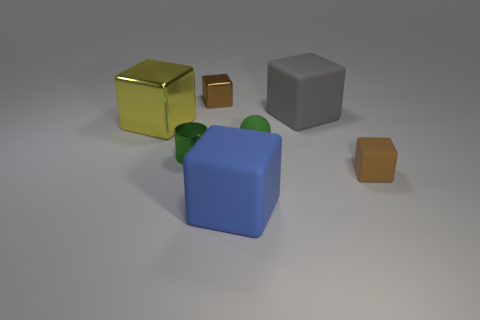Subtract all gray matte blocks. How many blocks are left? 4 Subtract all gray cylinders. How many brown cubes are left? 2 Subtract all brown cubes. How many cubes are left? 3 Add 1 big gray matte things. How many objects exist? 8 Subtract all cubes. How many objects are left? 2 Subtract 4 blocks. How many blocks are left? 1 Add 1 big shiny objects. How many big shiny objects are left? 2 Add 6 tiny cubes. How many tiny cubes exist? 8 Subtract 0 blue cylinders. How many objects are left? 7 Subtract all brown cylinders. Subtract all green spheres. How many cylinders are left? 1 